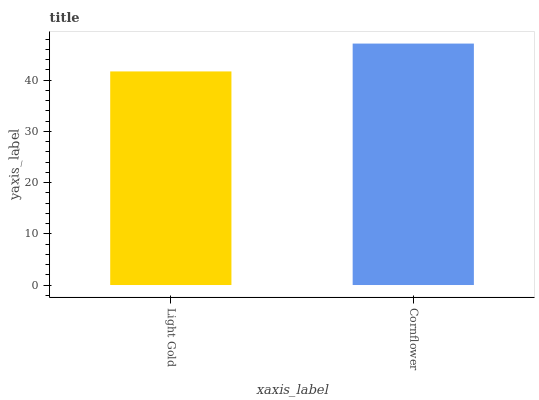Is Light Gold the minimum?
Answer yes or no. Yes. Is Cornflower the maximum?
Answer yes or no. Yes. Is Cornflower the minimum?
Answer yes or no. No. Is Cornflower greater than Light Gold?
Answer yes or no. Yes. Is Light Gold less than Cornflower?
Answer yes or no. Yes. Is Light Gold greater than Cornflower?
Answer yes or no. No. Is Cornflower less than Light Gold?
Answer yes or no. No. Is Cornflower the high median?
Answer yes or no. Yes. Is Light Gold the low median?
Answer yes or no. Yes. Is Light Gold the high median?
Answer yes or no. No. Is Cornflower the low median?
Answer yes or no. No. 